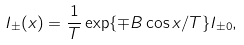<formula> <loc_0><loc_0><loc_500><loc_500>I _ { \pm } ( x ) = \frac { 1 } { T } \exp \{ \mp B \cos x / T \} I _ { \pm 0 } ,</formula> 